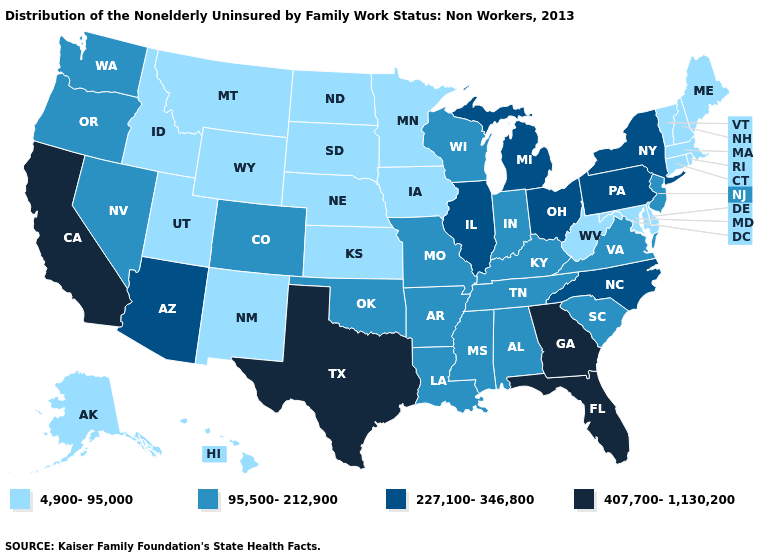Among the states that border Tennessee , which have the highest value?
Concise answer only. Georgia. What is the value of Montana?
Keep it brief. 4,900-95,000. Among the states that border Connecticut , does Massachusetts have the highest value?
Short answer required. No. Does the map have missing data?
Answer briefly. No. Name the states that have a value in the range 4,900-95,000?
Give a very brief answer. Alaska, Connecticut, Delaware, Hawaii, Idaho, Iowa, Kansas, Maine, Maryland, Massachusetts, Minnesota, Montana, Nebraska, New Hampshire, New Mexico, North Dakota, Rhode Island, South Dakota, Utah, Vermont, West Virginia, Wyoming. What is the highest value in states that border Tennessee?
Be succinct. 407,700-1,130,200. Name the states that have a value in the range 407,700-1,130,200?
Concise answer only. California, Florida, Georgia, Texas. Does the map have missing data?
Quick response, please. No. Name the states that have a value in the range 95,500-212,900?
Give a very brief answer. Alabama, Arkansas, Colorado, Indiana, Kentucky, Louisiana, Mississippi, Missouri, Nevada, New Jersey, Oklahoma, Oregon, South Carolina, Tennessee, Virginia, Washington, Wisconsin. What is the value of Utah?
Keep it brief. 4,900-95,000. Which states have the lowest value in the USA?
Concise answer only. Alaska, Connecticut, Delaware, Hawaii, Idaho, Iowa, Kansas, Maine, Maryland, Massachusetts, Minnesota, Montana, Nebraska, New Hampshire, New Mexico, North Dakota, Rhode Island, South Dakota, Utah, Vermont, West Virginia, Wyoming. What is the lowest value in states that border Arizona?
Be succinct. 4,900-95,000. Name the states that have a value in the range 4,900-95,000?
Short answer required. Alaska, Connecticut, Delaware, Hawaii, Idaho, Iowa, Kansas, Maine, Maryland, Massachusetts, Minnesota, Montana, Nebraska, New Hampshire, New Mexico, North Dakota, Rhode Island, South Dakota, Utah, Vermont, West Virginia, Wyoming. Name the states that have a value in the range 4,900-95,000?
Keep it brief. Alaska, Connecticut, Delaware, Hawaii, Idaho, Iowa, Kansas, Maine, Maryland, Massachusetts, Minnesota, Montana, Nebraska, New Hampshire, New Mexico, North Dakota, Rhode Island, South Dakota, Utah, Vermont, West Virginia, Wyoming. What is the value of Mississippi?
Write a very short answer. 95,500-212,900. 